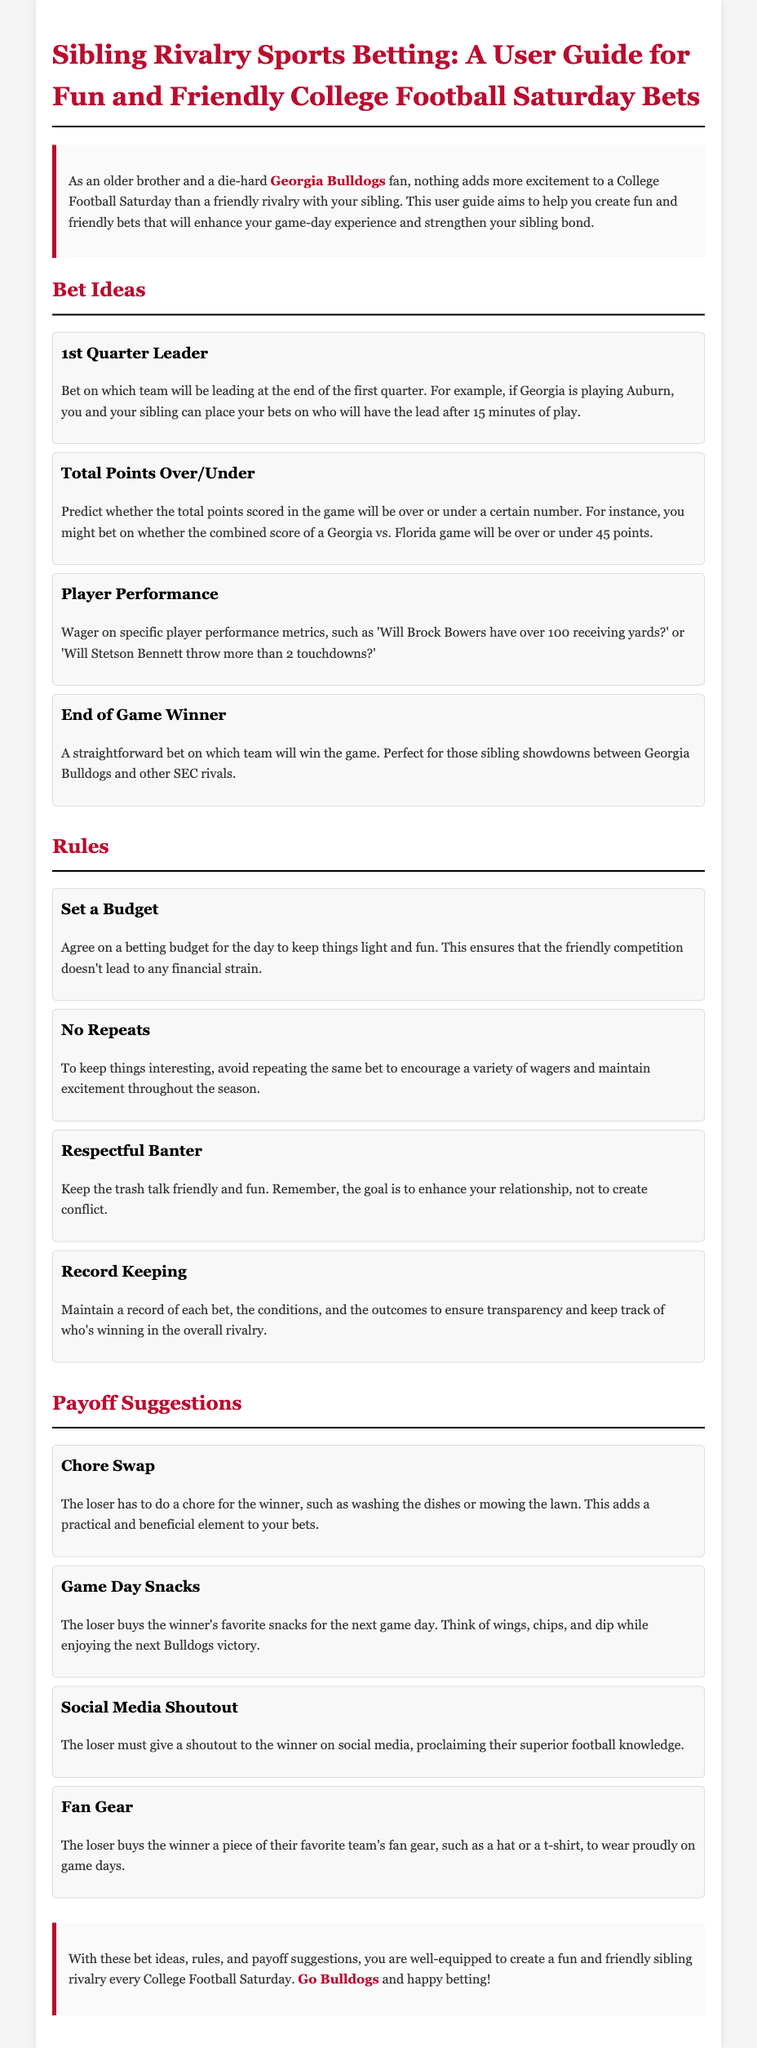What is the main focus of the user guide? The user guide focuses on creating fun and friendly bets with your sibling for College Football Saturdays.
Answer: fun and friendly bets How many bet ideas are listed in the document? The document lists four distinct bet ideas related to sports betting.
Answer: four What is the first payoff suggestion provided? The first payoff suggestion involves a chore swap where the loser has to do a chore for the winner.
Answer: Chore Swap What is one of the rules mentioned regarding the nature of bets? One rule mentioned is to avoid repeating the same bet to keep things interesting.
Answer: No Repeats What should the loser do as a social media payoff? The loser must give a shoutout to the winner on social media.
Answer: shoutout Which team's fan is the author of the guide? The author's favorite team, as stated in the document, is the Georgia Bulldogs.
Answer: Georgia Bulldogs What is suggested for the betting budget? It is suggested to agree on a betting budget for the day to keep the competition light.
Answer: Set a Budget What is the color associated with the Georgia Bulldogs in the document? The document emphasizes the color red associated with the Georgia Bulldogs.
Answer: red 